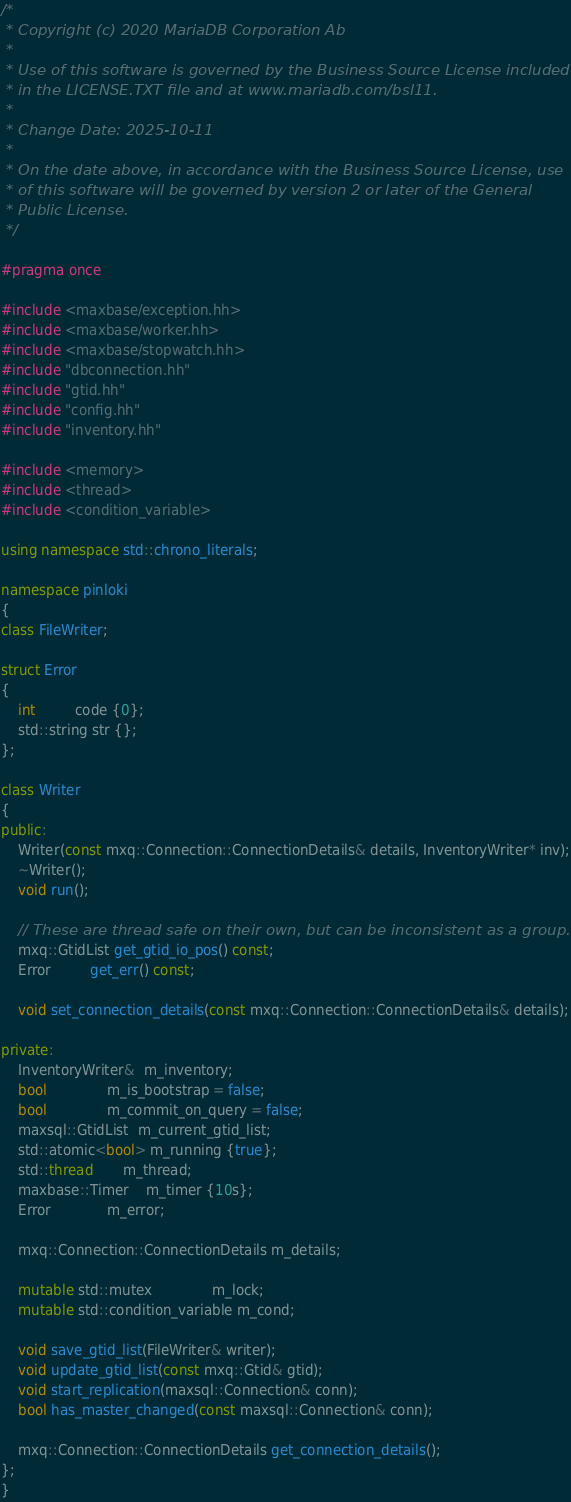<code> <loc_0><loc_0><loc_500><loc_500><_C++_>/*
 * Copyright (c) 2020 MariaDB Corporation Ab
 *
 * Use of this software is governed by the Business Source License included
 * in the LICENSE.TXT file and at www.mariadb.com/bsl11.
 *
 * Change Date: 2025-10-11
 *
 * On the date above, in accordance with the Business Source License, use
 * of this software will be governed by version 2 or later of the General
 * Public License.
 */

#pragma once

#include <maxbase/exception.hh>
#include <maxbase/worker.hh>
#include <maxbase/stopwatch.hh>
#include "dbconnection.hh"
#include "gtid.hh"
#include "config.hh"
#include "inventory.hh"

#include <memory>
#include <thread>
#include <condition_variable>

using namespace std::chrono_literals;

namespace pinloki
{
class FileWriter;

struct Error
{
    int         code {0};
    std::string str {};
};

class Writer
{
public:
    Writer(const mxq::Connection::ConnectionDetails& details, InventoryWriter* inv);
    ~Writer();
    void run();

    // These are thread safe on their own, but can be inconsistent as a group.
    mxq::GtidList get_gtid_io_pos() const;
    Error         get_err() const;

    void set_connection_details(const mxq::Connection::ConnectionDetails& details);

private:
    InventoryWriter&  m_inventory;
    bool              m_is_bootstrap = false;
    bool              m_commit_on_query = false;
    maxsql::GtidList  m_current_gtid_list;
    std::atomic<bool> m_running {true};
    std::thread       m_thread;
    maxbase::Timer    m_timer {10s};
    Error             m_error;

    mxq::Connection::ConnectionDetails m_details;

    mutable std::mutex              m_lock;
    mutable std::condition_variable m_cond;

    void save_gtid_list(FileWriter& writer);
    void update_gtid_list(const mxq::Gtid& gtid);
    void start_replication(maxsql::Connection& conn);
    bool has_master_changed(const maxsql::Connection& conn);

    mxq::Connection::ConnectionDetails get_connection_details();
};
}
</code> 